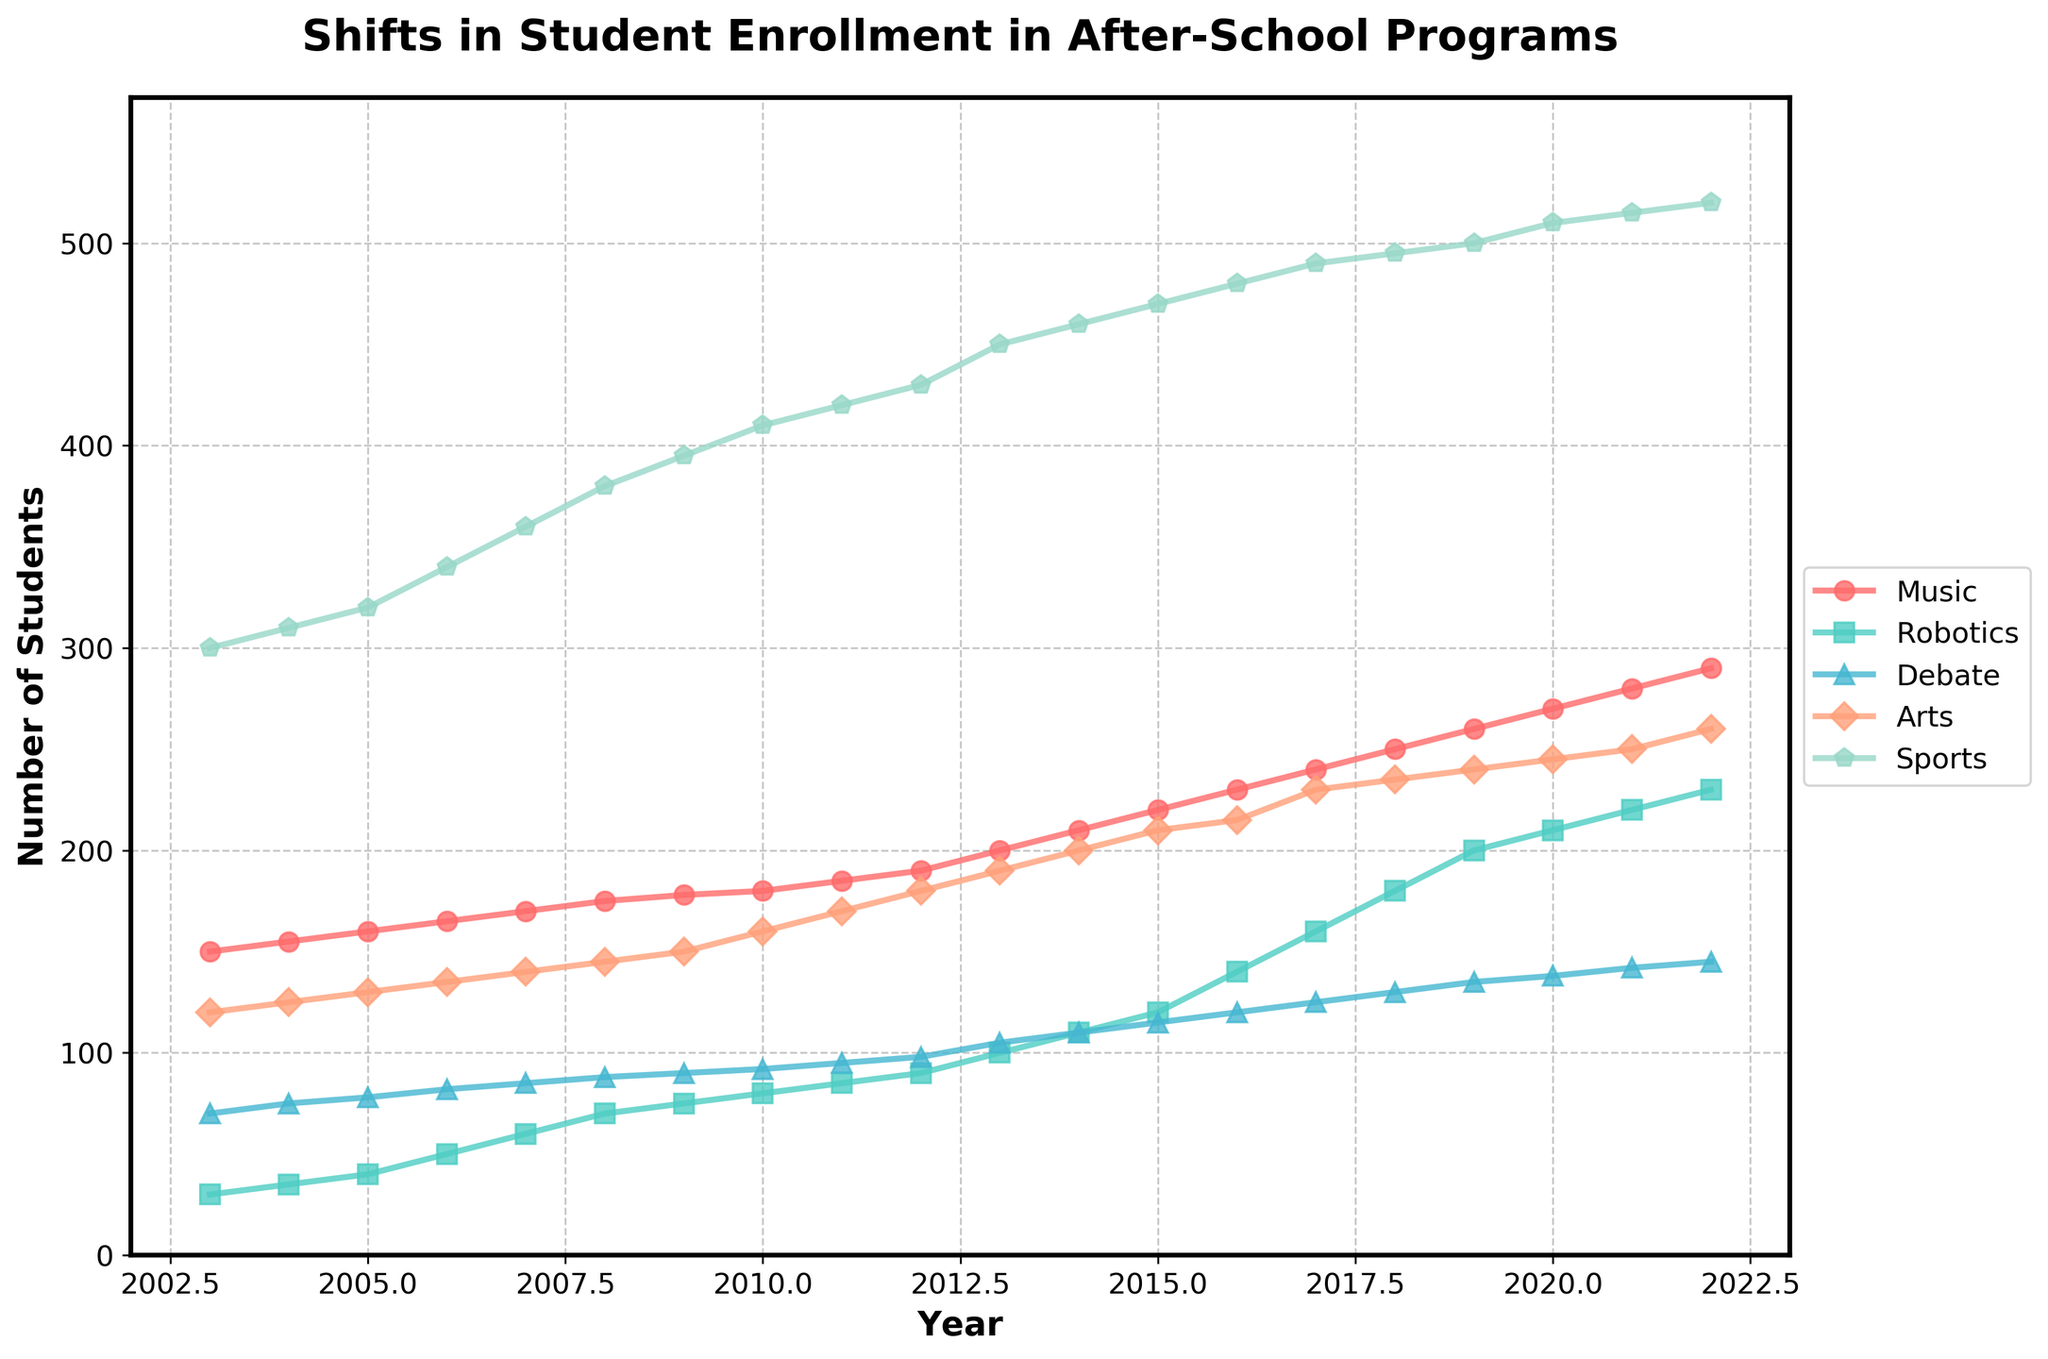What is the title of the plot? The title is positioned at the top of the plot and states "Shifts in Student Enrollment in After-School Programs".
Answer: Shifts in Student Enrollment in After-School Programs How many programs are tracked in the plot? By looking at the legend, we can see there are five different programs represented by different colors and markers: Music, Robotics, Debate, Arts, and Sports.
Answer: Five Which program had the highest enrollment in 2022? According to the y-axis value for the year 2022, the "Sports" program had the highest enrollment number.
Answer: Sports Which two programs had the closest enrollment numbers in 2015? Looking at the y-axis values for all programs in 2015, "Arts" (210) and "Debate" (115) have the closest enrollment numbers.
Answer: Debate and Arts What is the approximate enrollment difference between Music and Arts in 2010? From the y-axis in 2010: Music had around 180 students and Arts had around 160 students; thus, the difference is approximately 180 - 160 = 20 students.
Answer: 20 Which program showed the most significant growth from 2003 to 2022? By comparing the starting and ending y-axis values for each program, "Robotics" increased from 30 in 2003 to 230 in 2022, which is the most significant growth (200 students).
Answer: Robotics What is the trend for Robotics enrollment over the years? The line representing Robotics shows a consistent upward trend from 2003 to 2022, indicating a consistent increase in enrollment.
Answer: Increasing In what year did the Debate program surpass 100 enrollments? Referring to the y-axis for the Debate line, it surpasses 100 enrollments in the year 2013.
Answer: 2013 What is the overall pattern of Sports enrollment? The Sports enrollment line shows a steep and continuous increase from 2003 to 2022.
Answer: Continuously increasing How does the enrollment trend of Arts compare to that of Music? Both the Arts and Music programs show upward trends, but Music increases more steadily, while Arts has a slightly slower rate of increase.
Answer: Music increases more steadily, Arts slower rate 